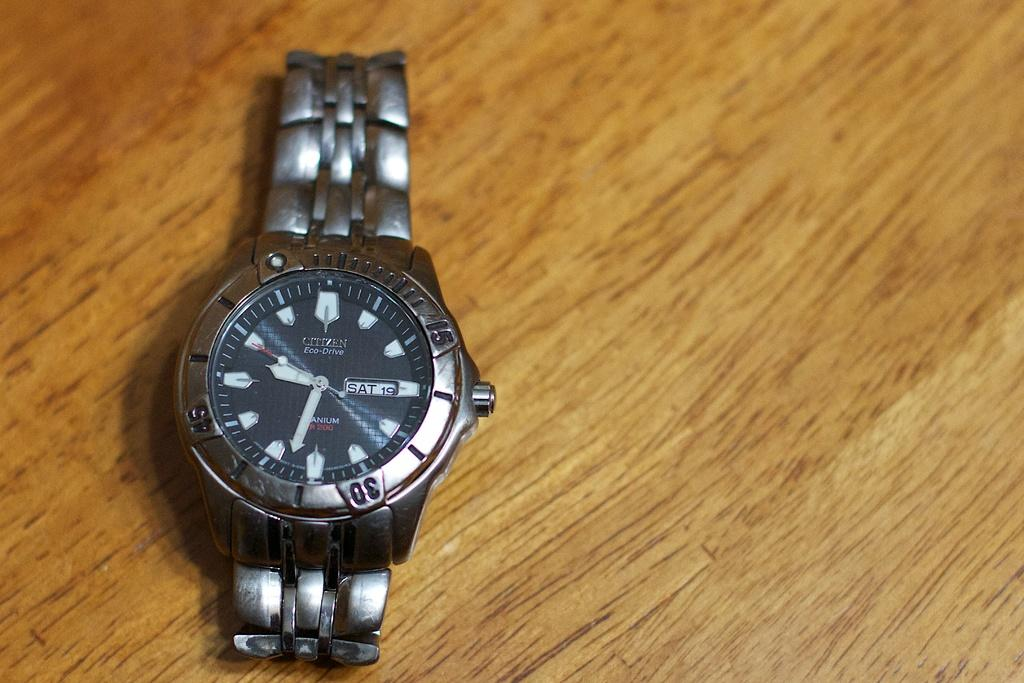<image>
Describe the image concisely. A watch shows that the day is "SAT." 